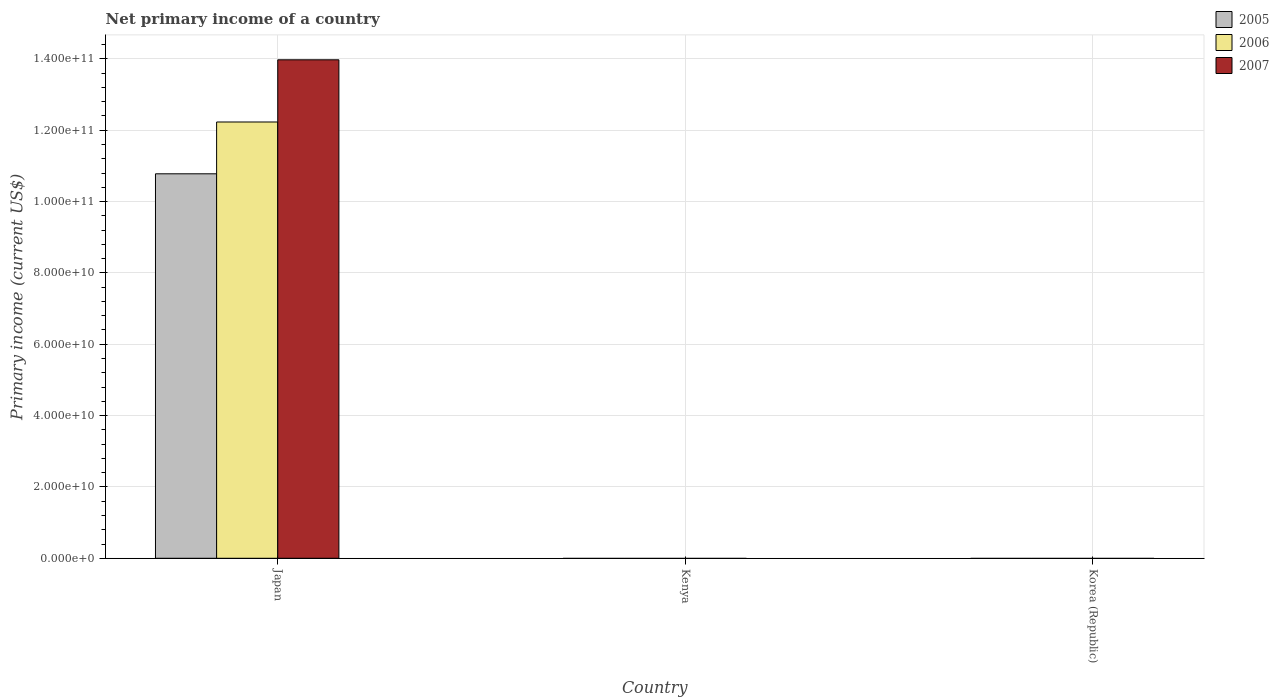How many different coloured bars are there?
Your answer should be compact. 3. Are the number of bars on each tick of the X-axis equal?
Ensure brevity in your answer.  No. How many bars are there on the 2nd tick from the left?
Provide a short and direct response. 0. How many bars are there on the 2nd tick from the right?
Provide a succinct answer. 0. In how many cases, is the number of bars for a given country not equal to the number of legend labels?
Offer a terse response. 2. What is the primary income in 2006 in Japan?
Your answer should be compact. 1.22e+11. Across all countries, what is the maximum primary income in 2006?
Make the answer very short. 1.22e+11. Across all countries, what is the minimum primary income in 2005?
Your answer should be very brief. 0. What is the total primary income in 2007 in the graph?
Your answer should be compact. 1.40e+11. What is the difference between the primary income in 2006 in Kenya and the primary income in 2007 in Korea (Republic)?
Offer a very short reply. 0. What is the average primary income in 2007 per country?
Your response must be concise. 4.66e+1. What is the difference between the primary income of/in 2005 and primary income of/in 2007 in Japan?
Give a very brief answer. -3.20e+1. What is the difference between the highest and the lowest primary income in 2005?
Offer a terse response. 1.08e+11. In how many countries, is the primary income in 2006 greater than the average primary income in 2006 taken over all countries?
Ensure brevity in your answer.  1. Is it the case that in every country, the sum of the primary income in 2006 and primary income in 2007 is greater than the primary income in 2005?
Give a very brief answer. No. What is the difference between two consecutive major ticks on the Y-axis?
Your response must be concise. 2.00e+1. Are the values on the major ticks of Y-axis written in scientific E-notation?
Give a very brief answer. Yes. Where does the legend appear in the graph?
Your answer should be compact. Top right. How many legend labels are there?
Offer a very short reply. 3. What is the title of the graph?
Offer a very short reply. Net primary income of a country. Does "1960" appear as one of the legend labels in the graph?
Ensure brevity in your answer.  No. What is the label or title of the Y-axis?
Offer a terse response. Primary income (current US$). What is the Primary income (current US$) of 2005 in Japan?
Ensure brevity in your answer.  1.08e+11. What is the Primary income (current US$) in 2006 in Japan?
Make the answer very short. 1.22e+11. What is the Primary income (current US$) of 2007 in Japan?
Provide a succinct answer. 1.40e+11. What is the Primary income (current US$) in 2007 in Kenya?
Your response must be concise. 0. What is the Primary income (current US$) in 2006 in Korea (Republic)?
Your response must be concise. 0. Across all countries, what is the maximum Primary income (current US$) of 2005?
Your response must be concise. 1.08e+11. Across all countries, what is the maximum Primary income (current US$) in 2006?
Make the answer very short. 1.22e+11. Across all countries, what is the maximum Primary income (current US$) of 2007?
Your response must be concise. 1.40e+11. Across all countries, what is the minimum Primary income (current US$) in 2007?
Offer a terse response. 0. What is the total Primary income (current US$) in 2005 in the graph?
Offer a very short reply. 1.08e+11. What is the total Primary income (current US$) of 2006 in the graph?
Provide a short and direct response. 1.22e+11. What is the total Primary income (current US$) in 2007 in the graph?
Your answer should be compact. 1.40e+11. What is the average Primary income (current US$) in 2005 per country?
Offer a terse response. 3.59e+1. What is the average Primary income (current US$) of 2006 per country?
Keep it short and to the point. 4.08e+1. What is the average Primary income (current US$) in 2007 per country?
Provide a short and direct response. 4.66e+1. What is the difference between the Primary income (current US$) of 2005 and Primary income (current US$) of 2006 in Japan?
Provide a short and direct response. -1.45e+1. What is the difference between the Primary income (current US$) in 2005 and Primary income (current US$) in 2007 in Japan?
Keep it short and to the point. -3.20e+1. What is the difference between the Primary income (current US$) of 2006 and Primary income (current US$) of 2007 in Japan?
Provide a succinct answer. -1.74e+1. What is the difference between the highest and the lowest Primary income (current US$) in 2005?
Make the answer very short. 1.08e+11. What is the difference between the highest and the lowest Primary income (current US$) of 2006?
Provide a short and direct response. 1.22e+11. What is the difference between the highest and the lowest Primary income (current US$) of 2007?
Keep it short and to the point. 1.40e+11. 